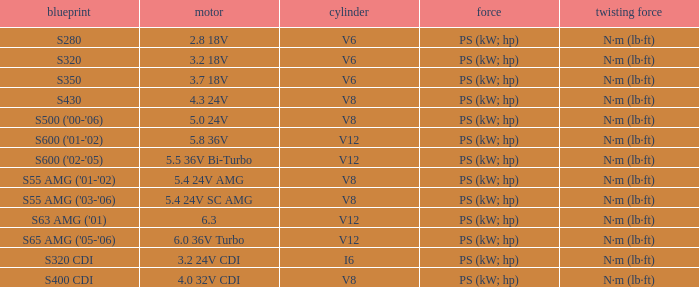Which Engine has a Model of s430? 4.3 24V. 